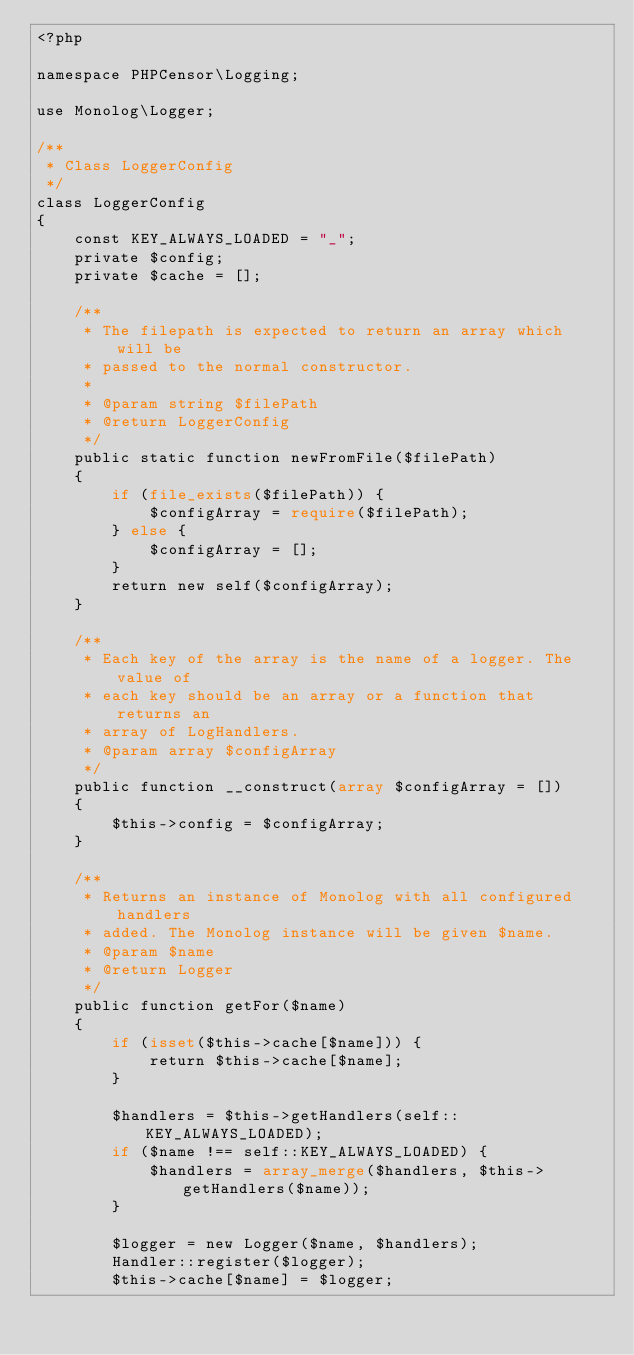Convert code to text. <code><loc_0><loc_0><loc_500><loc_500><_PHP_><?php

namespace PHPCensor\Logging;

use Monolog\Logger;

/**
 * Class LoggerConfig
 */
class LoggerConfig
{
    const KEY_ALWAYS_LOADED = "_";
    private $config;
    private $cache = [];

    /**
     * The filepath is expected to return an array which will be
     * passed to the normal constructor.
     *
     * @param string $filePath
     * @return LoggerConfig
     */
    public static function newFromFile($filePath)
    {
        if (file_exists($filePath)) {
            $configArray = require($filePath);
        } else {
            $configArray = [];
        }
        return new self($configArray);
    }

    /**
     * Each key of the array is the name of a logger. The value of
     * each key should be an array or a function that returns an
     * array of LogHandlers.
     * @param array $configArray
     */
    public function __construct(array $configArray = [])
    {
        $this->config = $configArray;
    }

    /**
     * Returns an instance of Monolog with all configured handlers
     * added. The Monolog instance will be given $name.
     * @param $name
     * @return Logger
     */
    public function getFor($name)
    {
        if (isset($this->cache[$name])) {
            return $this->cache[$name];
        }

        $handlers = $this->getHandlers(self::KEY_ALWAYS_LOADED);
        if ($name !== self::KEY_ALWAYS_LOADED) {
            $handlers = array_merge($handlers, $this->getHandlers($name));
        }

        $logger = new Logger($name, $handlers);
        Handler::register($logger);
        $this->cache[$name] = $logger;
</code> 